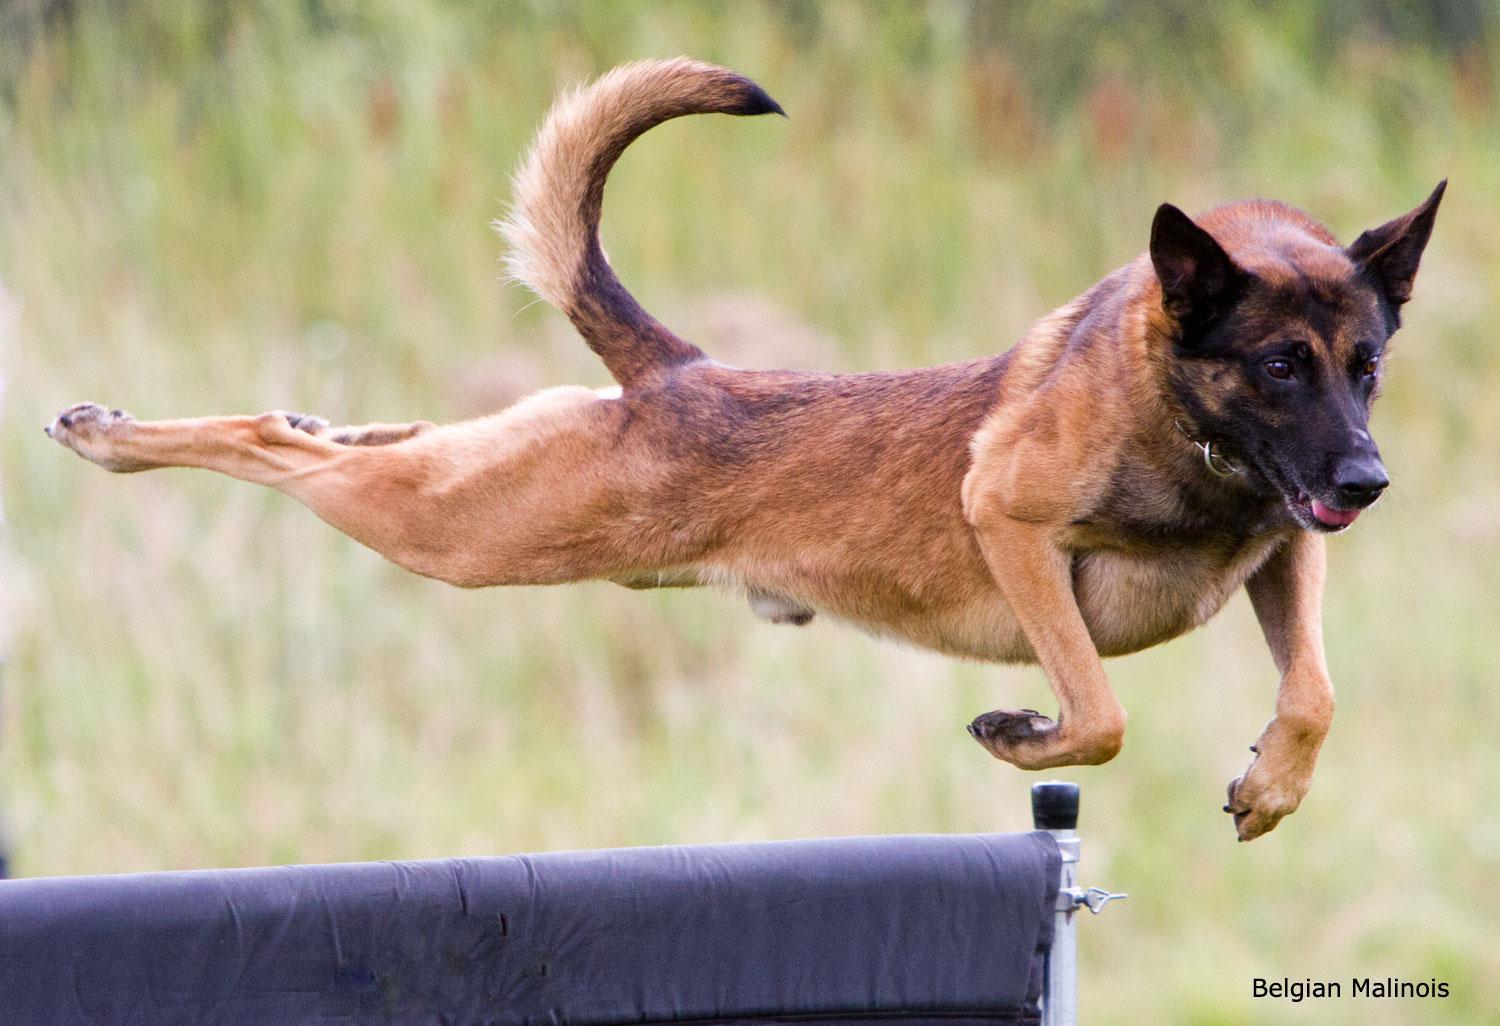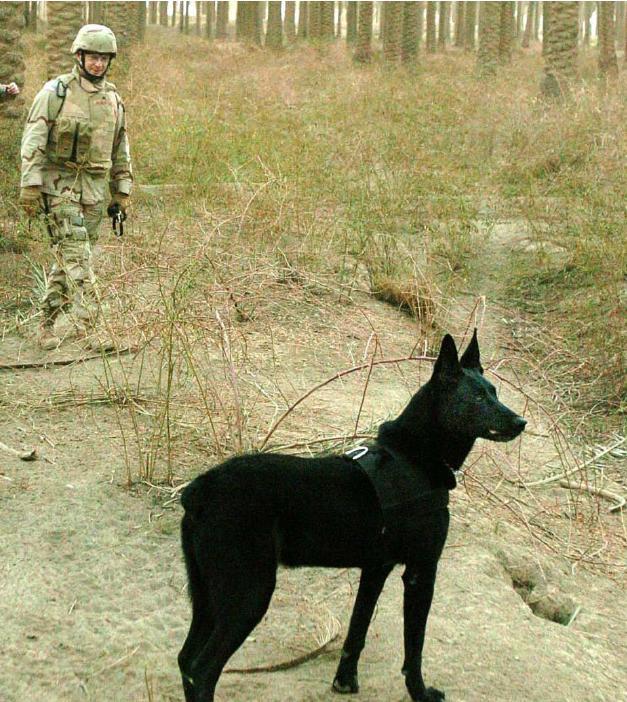The first image is the image on the left, the second image is the image on the right. Analyze the images presented: Is the assertion "A person in camo attire interacts with a dog in both images." valid? Answer yes or no. No. The first image is the image on the left, the second image is the image on the right. Examine the images to the left and right. Is the description "The dog is showing its teeth to the person wearing camo." accurate? Answer yes or no. No. 